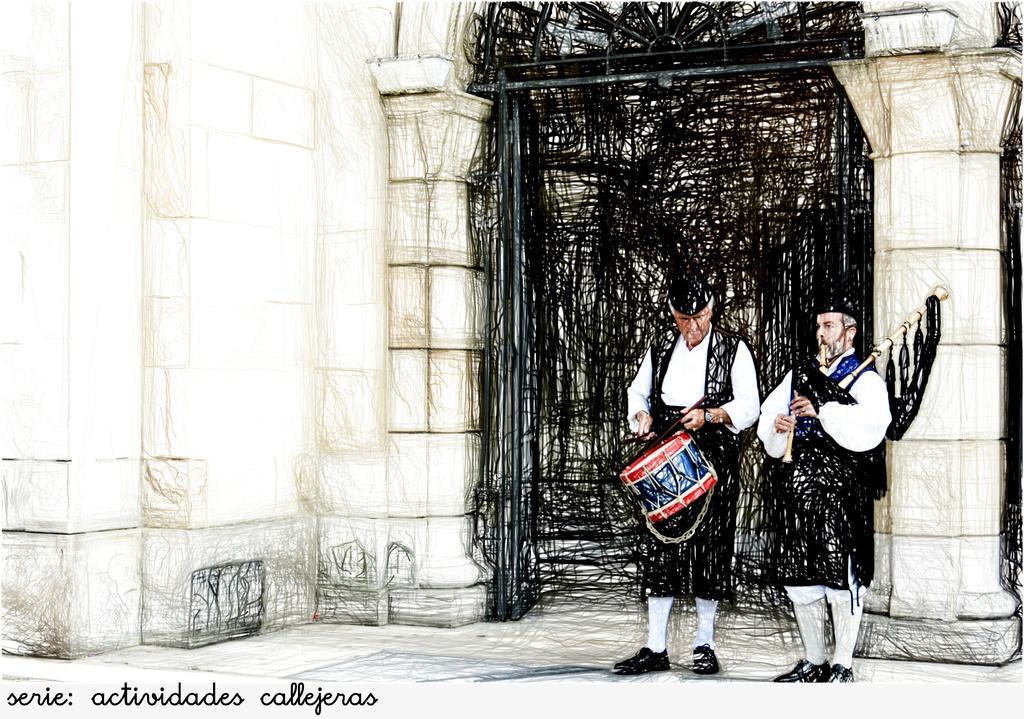In one or two sentences, can you explain what this image depicts? This is a drawing in this image there are two persons who are standing and they are holding some musical instruments, in the background there is a gate and a wall. At the bottom of the image there is some text. 